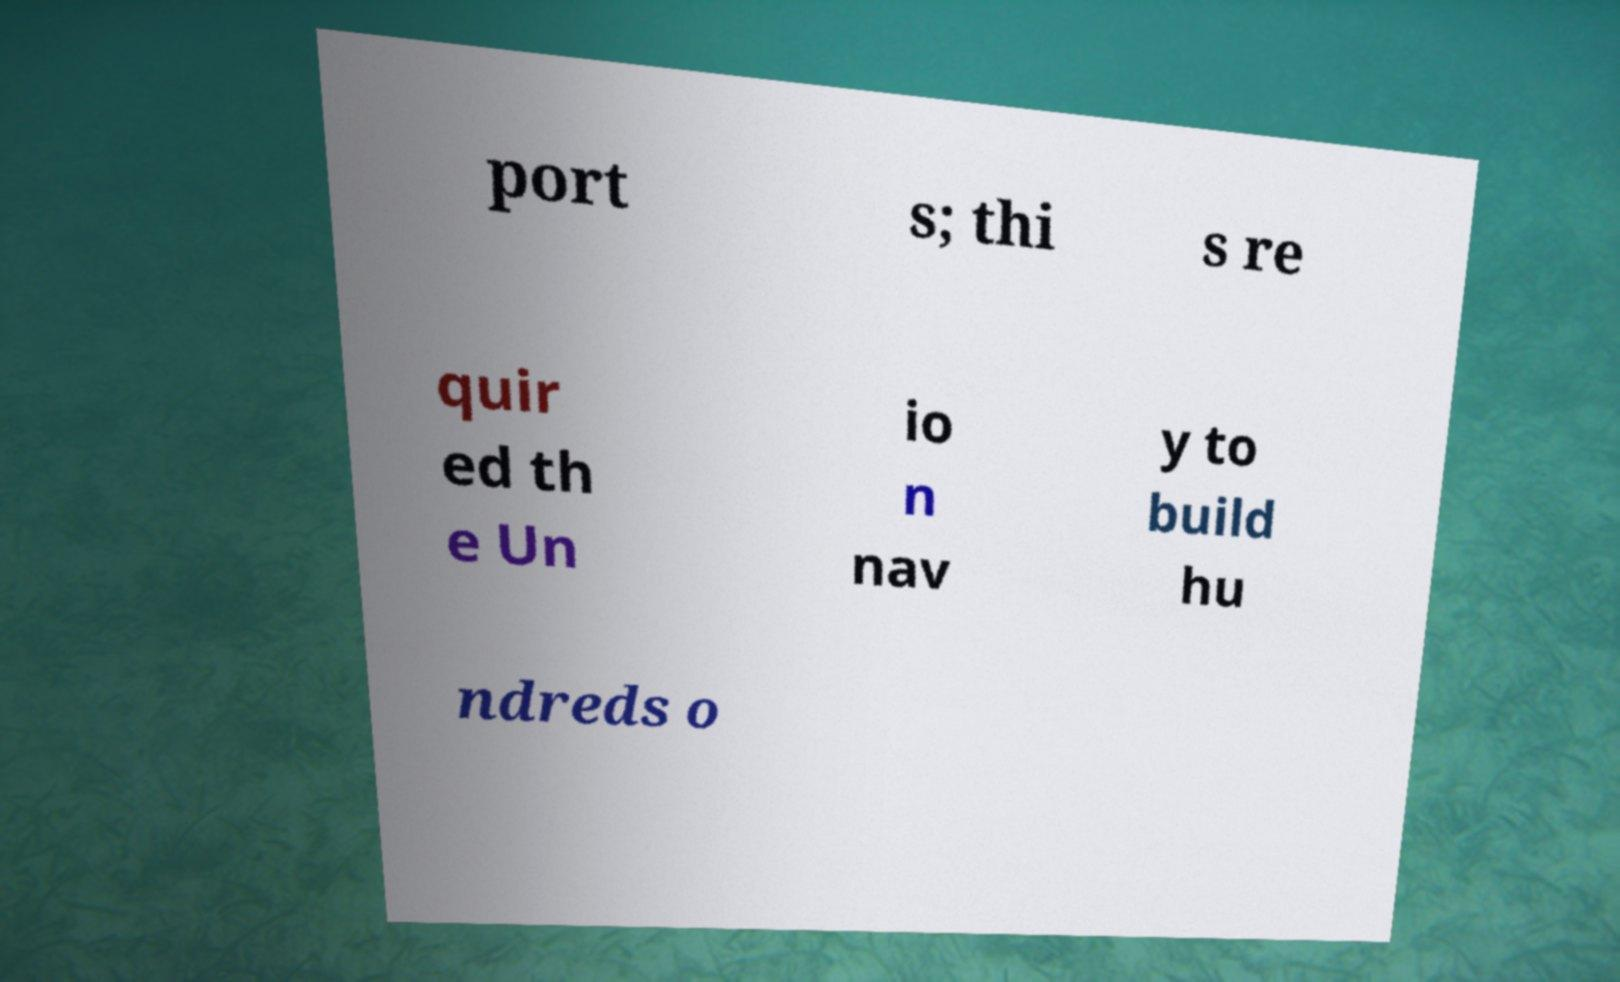Please identify and transcribe the text found in this image. port s; thi s re quir ed th e Un io n nav y to build hu ndreds o 